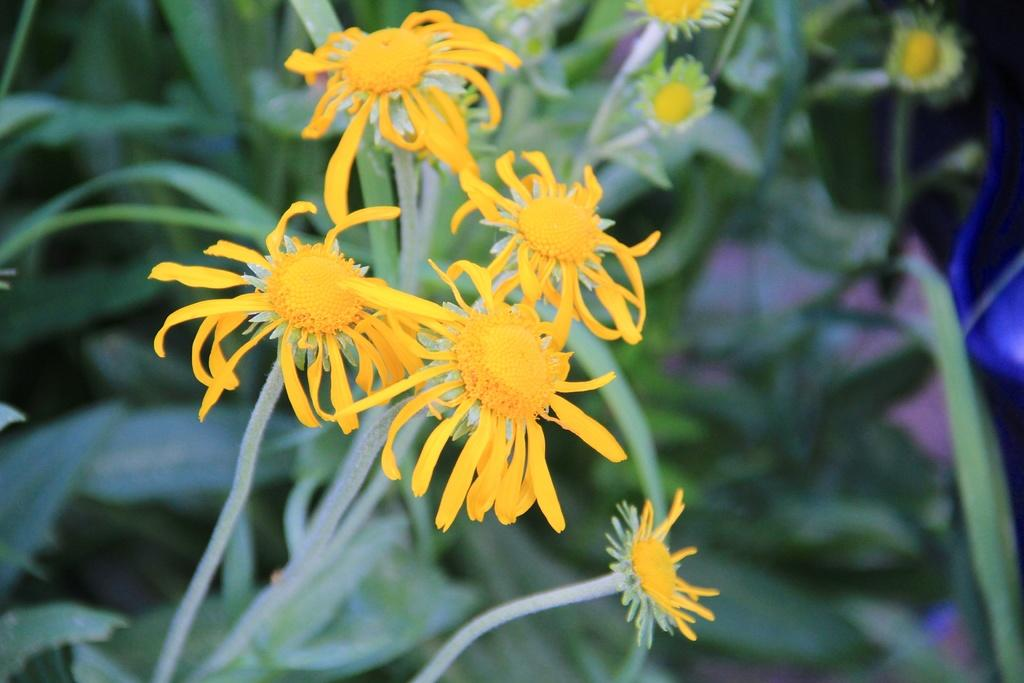What celestial bodies are depicted in the image? There are planets in the image. What type of flora can be seen in the image? There are yellow and white flowers in the image. Can you describe the background of the image? The background of the image is blurred. Are the people in the image fighting over the flowers? There are no people present in the image; it features planets and flowers with a blurred background. 